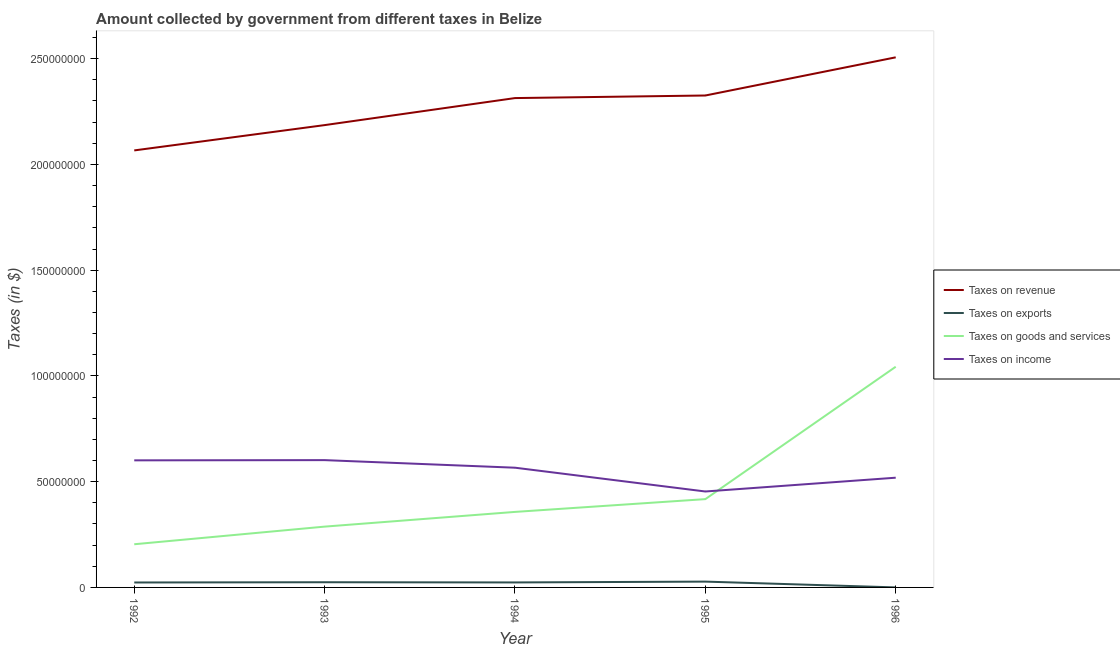Is the number of lines equal to the number of legend labels?
Provide a short and direct response. Yes. What is the amount collected as tax on income in 1996?
Your response must be concise. 5.19e+07. Across all years, what is the maximum amount collected as tax on exports?
Offer a very short reply. 2.75e+06. Across all years, what is the minimum amount collected as tax on goods?
Your answer should be compact. 2.04e+07. In which year was the amount collected as tax on income maximum?
Your answer should be very brief. 1993. What is the total amount collected as tax on revenue in the graph?
Provide a short and direct response. 1.14e+09. What is the difference between the amount collected as tax on revenue in 1992 and that in 1993?
Your answer should be very brief. -1.20e+07. What is the difference between the amount collected as tax on goods in 1994 and the amount collected as tax on exports in 1995?
Make the answer very short. 3.30e+07. What is the average amount collected as tax on goods per year?
Ensure brevity in your answer.  4.62e+07. In the year 1996, what is the difference between the amount collected as tax on revenue and amount collected as tax on income?
Offer a terse response. 1.99e+08. What is the ratio of the amount collected as tax on revenue in 1992 to that in 1995?
Give a very brief answer. 0.89. Is the difference between the amount collected as tax on income in 1995 and 1996 greater than the difference between the amount collected as tax on exports in 1995 and 1996?
Provide a succinct answer. No. What is the difference between the highest and the second highest amount collected as tax on goods?
Provide a succinct answer. 6.26e+07. What is the difference between the highest and the lowest amount collected as tax on exports?
Your answer should be compact. 2.74e+06. Is the sum of the amount collected as tax on goods in 1992 and 1996 greater than the maximum amount collected as tax on exports across all years?
Your answer should be compact. Yes. Is it the case that in every year, the sum of the amount collected as tax on revenue and amount collected as tax on exports is greater than the amount collected as tax on goods?
Ensure brevity in your answer.  Yes. How many years are there in the graph?
Give a very brief answer. 5. What is the difference between two consecutive major ticks on the Y-axis?
Provide a succinct answer. 5.00e+07. Are the values on the major ticks of Y-axis written in scientific E-notation?
Ensure brevity in your answer.  No. Does the graph contain any zero values?
Offer a terse response. No. Does the graph contain grids?
Your answer should be compact. No. How many legend labels are there?
Offer a terse response. 4. How are the legend labels stacked?
Ensure brevity in your answer.  Vertical. What is the title of the graph?
Your response must be concise. Amount collected by government from different taxes in Belize. Does "Oil" appear as one of the legend labels in the graph?
Your answer should be compact. No. What is the label or title of the X-axis?
Give a very brief answer. Year. What is the label or title of the Y-axis?
Provide a short and direct response. Taxes (in $). What is the Taxes (in $) in Taxes on revenue in 1992?
Provide a short and direct response. 2.07e+08. What is the Taxes (in $) of Taxes on exports in 1992?
Provide a short and direct response. 2.34e+06. What is the Taxes (in $) in Taxes on goods and services in 1992?
Your answer should be very brief. 2.04e+07. What is the Taxes (in $) in Taxes on income in 1992?
Your answer should be compact. 6.01e+07. What is the Taxes (in $) of Taxes on revenue in 1993?
Your answer should be very brief. 2.19e+08. What is the Taxes (in $) of Taxes on exports in 1993?
Your answer should be very brief. 2.45e+06. What is the Taxes (in $) of Taxes on goods and services in 1993?
Give a very brief answer. 2.88e+07. What is the Taxes (in $) in Taxes on income in 1993?
Give a very brief answer. 6.02e+07. What is the Taxes (in $) in Taxes on revenue in 1994?
Make the answer very short. 2.31e+08. What is the Taxes (in $) in Taxes on exports in 1994?
Keep it short and to the point. 2.36e+06. What is the Taxes (in $) in Taxes on goods and services in 1994?
Your answer should be very brief. 3.57e+07. What is the Taxes (in $) of Taxes on income in 1994?
Your response must be concise. 5.66e+07. What is the Taxes (in $) of Taxes on revenue in 1995?
Your answer should be very brief. 2.33e+08. What is the Taxes (in $) in Taxes on exports in 1995?
Your answer should be compact. 2.75e+06. What is the Taxes (in $) in Taxes on goods and services in 1995?
Offer a very short reply. 4.17e+07. What is the Taxes (in $) of Taxes on income in 1995?
Your answer should be compact. 4.54e+07. What is the Taxes (in $) of Taxes on revenue in 1996?
Give a very brief answer. 2.51e+08. What is the Taxes (in $) of Taxes on exports in 1996?
Your response must be concise. 1.20e+04. What is the Taxes (in $) in Taxes on goods and services in 1996?
Provide a short and direct response. 1.04e+08. What is the Taxes (in $) in Taxes on income in 1996?
Make the answer very short. 5.19e+07. Across all years, what is the maximum Taxes (in $) of Taxes on revenue?
Your answer should be compact. 2.51e+08. Across all years, what is the maximum Taxes (in $) in Taxes on exports?
Provide a succinct answer. 2.75e+06. Across all years, what is the maximum Taxes (in $) of Taxes on goods and services?
Your answer should be compact. 1.04e+08. Across all years, what is the maximum Taxes (in $) in Taxes on income?
Offer a very short reply. 6.02e+07. Across all years, what is the minimum Taxes (in $) of Taxes on revenue?
Your response must be concise. 2.07e+08. Across all years, what is the minimum Taxes (in $) in Taxes on exports?
Your answer should be compact. 1.20e+04. Across all years, what is the minimum Taxes (in $) of Taxes on goods and services?
Your response must be concise. 2.04e+07. Across all years, what is the minimum Taxes (in $) in Taxes on income?
Your response must be concise. 4.54e+07. What is the total Taxes (in $) of Taxes on revenue in the graph?
Keep it short and to the point. 1.14e+09. What is the total Taxes (in $) in Taxes on exports in the graph?
Offer a terse response. 9.91e+06. What is the total Taxes (in $) of Taxes on goods and services in the graph?
Make the answer very short. 2.31e+08. What is the total Taxes (in $) of Taxes on income in the graph?
Ensure brevity in your answer.  2.74e+08. What is the difference between the Taxes (in $) in Taxes on revenue in 1992 and that in 1993?
Offer a very short reply. -1.20e+07. What is the difference between the Taxes (in $) of Taxes on exports in 1992 and that in 1993?
Offer a terse response. -1.17e+05. What is the difference between the Taxes (in $) of Taxes on goods and services in 1992 and that in 1993?
Offer a terse response. -8.34e+06. What is the difference between the Taxes (in $) of Taxes on income in 1992 and that in 1993?
Provide a short and direct response. -1.07e+05. What is the difference between the Taxes (in $) of Taxes on revenue in 1992 and that in 1994?
Provide a short and direct response. -2.47e+07. What is the difference between the Taxes (in $) in Taxes on exports in 1992 and that in 1994?
Your answer should be compact. -2.20e+04. What is the difference between the Taxes (in $) of Taxes on goods and services in 1992 and that in 1994?
Offer a very short reply. -1.53e+07. What is the difference between the Taxes (in $) in Taxes on income in 1992 and that in 1994?
Provide a succinct answer. 3.48e+06. What is the difference between the Taxes (in $) in Taxes on revenue in 1992 and that in 1995?
Your response must be concise. -2.60e+07. What is the difference between the Taxes (in $) of Taxes on exports in 1992 and that in 1995?
Ensure brevity in your answer.  -4.11e+05. What is the difference between the Taxes (in $) of Taxes on goods and services in 1992 and that in 1995?
Keep it short and to the point. -2.13e+07. What is the difference between the Taxes (in $) of Taxes on income in 1992 and that in 1995?
Provide a succinct answer. 1.47e+07. What is the difference between the Taxes (in $) of Taxes on revenue in 1992 and that in 1996?
Keep it short and to the point. -4.40e+07. What is the difference between the Taxes (in $) in Taxes on exports in 1992 and that in 1996?
Your response must be concise. 2.32e+06. What is the difference between the Taxes (in $) of Taxes on goods and services in 1992 and that in 1996?
Provide a succinct answer. -8.39e+07. What is the difference between the Taxes (in $) in Taxes on income in 1992 and that in 1996?
Your answer should be very brief. 8.20e+06. What is the difference between the Taxes (in $) in Taxes on revenue in 1993 and that in 1994?
Provide a short and direct response. -1.28e+07. What is the difference between the Taxes (in $) of Taxes on exports in 1993 and that in 1994?
Provide a short and direct response. 9.50e+04. What is the difference between the Taxes (in $) of Taxes on goods and services in 1993 and that in 1994?
Provide a short and direct response. -6.96e+06. What is the difference between the Taxes (in $) of Taxes on income in 1993 and that in 1994?
Make the answer very short. 3.58e+06. What is the difference between the Taxes (in $) in Taxes on revenue in 1993 and that in 1995?
Keep it short and to the point. -1.40e+07. What is the difference between the Taxes (in $) of Taxes on exports in 1993 and that in 1995?
Your answer should be compact. -2.94e+05. What is the difference between the Taxes (in $) in Taxes on goods and services in 1993 and that in 1995?
Offer a terse response. -1.30e+07. What is the difference between the Taxes (in $) in Taxes on income in 1993 and that in 1995?
Your answer should be compact. 1.48e+07. What is the difference between the Taxes (in $) of Taxes on revenue in 1993 and that in 1996?
Provide a succinct answer. -3.20e+07. What is the difference between the Taxes (in $) in Taxes on exports in 1993 and that in 1996?
Give a very brief answer. 2.44e+06. What is the difference between the Taxes (in $) in Taxes on goods and services in 1993 and that in 1996?
Offer a terse response. -7.56e+07. What is the difference between the Taxes (in $) of Taxes on income in 1993 and that in 1996?
Keep it short and to the point. 8.31e+06. What is the difference between the Taxes (in $) of Taxes on revenue in 1994 and that in 1995?
Ensure brevity in your answer.  -1.22e+06. What is the difference between the Taxes (in $) in Taxes on exports in 1994 and that in 1995?
Make the answer very short. -3.89e+05. What is the difference between the Taxes (in $) of Taxes on goods and services in 1994 and that in 1995?
Give a very brief answer. -6.04e+06. What is the difference between the Taxes (in $) in Taxes on income in 1994 and that in 1995?
Keep it short and to the point. 1.12e+07. What is the difference between the Taxes (in $) in Taxes on revenue in 1994 and that in 1996?
Offer a very short reply. -1.93e+07. What is the difference between the Taxes (in $) in Taxes on exports in 1994 and that in 1996?
Your answer should be very brief. 2.35e+06. What is the difference between the Taxes (in $) in Taxes on goods and services in 1994 and that in 1996?
Provide a succinct answer. -6.86e+07. What is the difference between the Taxes (in $) in Taxes on income in 1994 and that in 1996?
Your answer should be very brief. 4.73e+06. What is the difference between the Taxes (in $) of Taxes on revenue in 1995 and that in 1996?
Provide a succinct answer. -1.80e+07. What is the difference between the Taxes (in $) of Taxes on exports in 1995 and that in 1996?
Your response must be concise. 2.74e+06. What is the difference between the Taxes (in $) of Taxes on goods and services in 1995 and that in 1996?
Provide a short and direct response. -6.26e+07. What is the difference between the Taxes (in $) of Taxes on income in 1995 and that in 1996?
Provide a short and direct response. -6.52e+06. What is the difference between the Taxes (in $) of Taxes on revenue in 1992 and the Taxes (in $) of Taxes on exports in 1993?
Your answer should be compact. 2.04e+08. What is the difference between the Taxes (in $) in Taxes on revenue in 1992 and the Taxes (in $) in Taxes on goods and services in 1993?
Your response must be concise. 1.78e+08. What is the difference between the Taxes (in $) in Taxes on revenue in 1992 and the Taxes (in $) in Taxes on income in 1993?
Provide a short and direct response. 1.46e+08. What is the difference between the Taxes (in $) in Taxes on exports in 1992 and the Taxes (in $) in Taxes on goods and services in 1993?
Provide a short and direct response. -2.64e+07. What is the difference between the Taxes (in $) in Taxes on exports in 1992 and the Taxes (in $) in Taxes on income in 1993?
Keep it short and to the point. -5.79e+07. What is the difference between the Taxes (in $) of Taxes on goods and services in 1992 and the Taxes (in $) of Taxes on income in 1993?
Your answer should be very brief. -3.98e+07. What is the difference between the Taxes (in $) in Taxes on revenue in 1992 and the Taxes (in $) in Taxes on exports in 1994?
Offer a terse response. 2.04e+08. What is the difference between the Taxes (in $) in Taxes on revenue in 1992 and the Taxes (in $) in Taxes on goods and services in 1994?
Make the answer very short. 1.71e+08. What is the difference between the Taxes (in $) of Taxes on revenue in 1992 and the Taxes (in $) of Taxes on income in 1994?
Provide a short and direct response. 1.50e+08. What is the difference between the Taxes (in $) of Taxes on exports in 1992 and the Taxes (in $) of Taxes on goods and services in 1994?
Make the answer very short. -3.34e+07. What is the difference between the Taxes (in $) of Taxes on exports in 1992 and the Taxes (in $) of Taxes on income in 1994?
Offer a terse response. -5.43e+07. What is the difference between the Taxes (in $) of Taxes on goods and services in 1992 and the Taxes (in $) of Taxes on income in 1994?
Provide a succinct answer. -3.62e+07. What is the difference between the Taxes (in $) in Taxes on revenue in 1992 and the Taxes (in $) in Taxes on exports in 1995?
Offer a very short reply. 2.04e+08. What is the difference between the Taxes (in $) of Taxes on revenue in 1992 and the Taxes (in $) of Taxes on goods and services in 1995?
Give a very brief answer. 1.65e+08. What is the difference between the Taxes (in $) in Taxes on revenue in 1992 and the Taxes (in $) in Taxes on income in 1995?
Provide a succinct answer. 1.61e+08. What is the difference between the Taxes (in $) of Taxes on exports in 1992 and the Taxes (in $) of Taxes on goods and services in 1995?
Offer a terse response. -3.94e+07. What is the difference between the Taxes (in $) in Taxes on exports in 1992 and the Taxes (in $) in Taxes on income in 1995?
Keep it short and to the point. -4.30e+07. What is the difference between the Taxes (in $) in Taxes on goods and services in 1992 and the Taxes (in $) in Taxes on income in 1995?
Give a very brief answer. -2.49e+07. What is the difference between the Taxes (in $) of Taxes on revenue in 1992 and the Taxes (in $) of Taxes on exports in 1996?
Keep it short and to the point. 2.07e+08. What is the difference between the Taxes (in $) of Taxes on revenue in 1992 and the Taxes (in $) of Taxes on goods and services in 1996?
Provide a short and direct response. 1.02e+08. What is the difference between the Taxes (in $) in Taxes on revenue in 1992 and the Taxes (in $) in Taxes on income in 1996?
Provide a short and direct response. 1.55e+08. What is the difference between the Taxes (in $) in Taxes on exports in 1992 and the Taxes (in $) in Taxes on goods and services in 1996?
Provide a short and direct response. -1.02e+08. What is the difference between the Taxes (in $) of Taxes on exports in 1992 and the Taxes (in $) of Taxes on income in 1996?
Ensure brevity in your answer.  -4.95e+07. What is the difference between the Taxes (in $) of Taxes on goods and services in 1992 and the Taxes (in $) of Taxes on income in 1996?
Your answer should be compact. -3.15e+07. What is the difference between the Taxes (in $) in Taxes on revenue in 1993 and the Taxes (in $) in Taxes on exports in 1994?
Provide a succinct answer. 2.16e+08. What is the difference between the Taxes (in $) in Taxes on revenue in 1993 and the Taxes (in $) in Taxes on goods and services in 1994?
Provide a short and direct response. 1.83e+08. What is the difference between the Taxes (in $) of Taxes on revenue in 1993 and the Taxes (in $) of Taxes on income in 1994?
Keep it short and to the point. 1.62e+08. What is the difference between the Taxes (in $) in Taxes on exports in 1993 and the Taxes (in $) in Taxes on goods and services in 1994?
Offer a terse response. -3.33e+07. What is the difference between the Taxes (in $) of Taxes on exports in 1993 and the Taxes (in $) of Taxes on income in 1994?
Offer a very short reply. -5.42e+07. What is the difference between the Taxes (in $) of Taxes on goods and services in 1993 and the Taxes (in $) of Taxes on income in 1994?
Provide a succinct answer. -2.79e+07. What is the difference between the Taxes (in $) in Taxes on revenue in 1993 and the Taxes (in $) in Taxes on exports in 1995?
Provide a short and direct response. 2.16e+08. What is the difference between the Taxes (in $) of Taxes on revenue in 1993 and the Taxes (in $) of Taxes on goods and services in 1995?
Provide a succinct answer. 1.77e+08. What is the difference between the Taxes (in $) in Taxes on revenue in 1993 and the Taxes (in $) in Taxes on income in 1995?
Give a very brief answer. 1.73e+08. What is the difference between the Taxes (in $) in Taxes on exports in 1993 and the Taxes (in $) in Taxes on goods and services in 1995?
Offer a very short reply. -3.93e+07. What is the difference between the Taxes (in $) in Taxes on exports in 1993 and the Taxes (in $) in Taxes on income in 1995?
Offer a very short reply. -4.29e+07. What is the difference between the Taxes (in $) of Taxes on goods and services in 1993 and the Taxes (in $) of Taxes on income in 1995?
Offer a terse response. -1.66e+07. What is the difference between the Taxes (in $) in Taxes on revenue in 1993 and the Taxes (in $) in Taxes on exports in 1996?
Your answer should be very brief. 2.19e+08. What is the difference between the Taxes (in $) in Taxes on revenue in 1993 and the Taxes (in $) in Taxes on goods and services in 1996?
Your answer should be compact. 1.14e+08. What is the difference between the Taxes (in $) in Taxes on revenue in 1993 and the Taxes (in $) in Taxes on income in 1996?
Provide a succinct answer. 1.67e+08. What is the difference between the Taxes (in $) of Taxes on exports in 1993 and the Taxes (in $) of Taxes on goods and services in 1996?
Provide a short and direct response. -1.02e+08. What is the difference between the Taxes (in $) of Taxes on exports in 1993 and the Taxes (in $) of Taxes on income in 1996?
Give a very brief answer. -4.94e+07. What is the difference between the Taxes (in $) of Taxes on goods and services in 1993 and the Taxes (in $) of Taxes on income in 1996?
Ensure brevity in your answer.  -2.31e+07. What is the difference between the Taxes (in $) in Taxes on revenue in 1994 and the Taxes (in $) in Taxes on exports in 1995?
Provide a succinct answer. 2.29e+08. What is the difference between the Taxes (in $) in Taxes on revenue in 1994 and the Taxes (in $) in Taxes on goods and services in 1995?
Your answer should be very brief. 1.90e+08. What is the difference between the Taxes (in $) in Taxes on revenue in 1994 and the Taxes (in $) in Taxes on income in 1995?
Offer a terse response. 1.86e+08. What is the difference between the Taxes (in $) in Taxes on exports in 1994 and the Taxes (in $) in Taxes on goods and services in 1995?
Your answer should be compact. -3.94e+07. What is the difference between the Taxes (in $) of Taxes on exports in 1994 and the Taxes (in $) of Taxes on income in 1995?
Your response must be concise. -4.30e+07. What is the difference between the Taxes (in $) of Taxes on goods and services in 1994 and the Taxes (in $) of Taxes on income in 1995?
Offer a terse response. -9.65e+06. What is the difference between the Taxes (in $) in Taxes on revenue in 1994 and the Taxes (in $) in Taxes on exports in 1996?
Ensure brevity in your answer.  2.31e+08. What is the difference between the Taxes (in $) of Taxes on revenue in 1994 and the Taxes (in $) of Taxes on goods and services in 1996?
Ensure brevity in your answer.  1.27e+08. What is the difference between the Taxes (in $) in Taxes on revenue in 1994 and the Taxes (in $) in Taxes on income in 1996?
Ensure brevity in your answer.  1.79e+08. What is the difference between the Taxes (in $) of Taxes on exports in 1994 and the Taxes (in $) of Taxes on goods and services in 1996?
Make the answer very short. -1.02e+08. What is the difference between the Taxes (in $) in Taxes on exports in 1994 and the Taxes (in $) in Taxes on income in 1996?
Make the answer very short. -4.95e+07. What is the difference between the Taxes (in $) of Taxes on goods and services in 1994 and the Taxes (in $) of Taxes on income in 1996?
Provide a succinct answer. -1.62e+07. What is the difference between the Taxes (in $) of Taxes on revenue in 1995 and the Taxes (in $) of Taxes on exports in 1996?
Keep it short and to the point. 2.33e+08. What is the difference between the Taxes (in $) in Taxes on revenue in 1995 and the Taxes (in $) in Taxes on goods and services in 1996?
Offer a terse response. 1.28e+08. What is the difference between the Taxes (in $) of Taxes on revenue in 1995 and the Taxes (in $) of Taxes on income in 1996?
Provide a short and direct response. 1.81e+08. What is the difference between the Taxes (in $) in Taxes on exports in 1995 and the Taxes (in $) in Taxes on goods and services in 1996?
Your answer should be compact. -1.02e+08. What is the difference between the Taxes (in $) of Taxes on exports in 1995 and the Taxes (in $) of Taxes on income in 1996?
Offer a terse response. -4.91e+07. What is the difference between the Taxes (in $) of Taxes on goods and services in 1995 and the Taxes (in $) of Taxes on income in 1996?
Your response must be concise. -1.01e+07. What is the average Taxes (in $) in Taxes on revenue per year?
Your response must be concise. 2.28e+08. What is the average Taxes (in $) in Taxes on exports per year?
Your answer should be compact. 1.98e+06. What is the average Taxes (in $) in Taxes on goods and services per year?
Offer a terse response. 4.62e+07. What is the average Taxes (in $) in Taxes on income per year?
Give a very brief answer. 5.48e+07. In the year 1992, what is the difference between the Taxes (in $) of Taxes on revenue and Taxes (in $) of Taxes on exports?
Make the answer very short. 2.04e+08. In the year 1992, what is the difference between the Taxes (in $) of Taxes on revenue and Taxes (in $) of Taxes on goods and services?
Provide a short and direct response. 1.86e+08. In the year 1992, what is the difference between the Taxes (in $) of Taxes on revenue and Taxes (in $) of Taxes on income?
Keep it short and to the point. 1.47e+08. In the year 1992, what is the difference between the Taxes (in $) of Taxes on exports and Taxes (in $) of Taxes on goods and services?
Your answer should be compact. -1.81e+07. In the year 1992, what is the difference between the Taxes (in $) in Taxes on exports and Taxes (in $) in Taxes on income?
Offer a very short reply. -5.78e+07. In the year 1992, what is the difference between the Taxes (in $) in Taxes on goods and services and Taxes (in $) in Taxes on income?
Offer a very short reply. -3.97e+07. In the year 1993, what is the difference between the Taxes (in $) in Taxes on revenue and Taxes (in $) in Taxes on exports?
Your answer should be very brief. 2.16e+08. In the year 1993, what is the difference between the Taxes (in $) of Taxes on revenue and Taxes (in $) of Taxes on goods and services?
Provide a succinct answer. 1.90e+08. In the year 1993, what is the difference between the Taxes (in $) in Taxes on revenue and Taxes (in $) in Taxes on income?
Give a very brief answer. 1.58e+08. In the year 1993, what is the difference between the Taxes (in $) in Taxes on exports and Taxes (in $) in Taxes on goods and services?
Provide a short and direct response. -2.63e+07. In the year 1993, what is the difference between the Taxes (in $) in Taxes on exports and Taxes (in $) in Taxes on income?
Your answer should be very brief. -5.77e+07. In the year 1993, what is the difference between the Taxes (in $) in Taxes on goods and services and Taxes (in $) in Taxes on income?
Provide a succinct answer. -3.14e+07. In the year 1994, what is the difference between the Taxes (in $) of Taxes on revenue and Taxes (in $) of Taxes on exports?
Offer a very short reply. 2.29e+08. In the year 1994, what is the difference between the Taxes (in $) in Taxes on revenue and Taxes (in $) in Taxes on goods and services?
Provide a short and direct response. 1.96e+08. In the year 1994, what is the difference between the Taxes (in $) of Taxes on revenue and Taxes (in $) of Taxes on income?
Your response must be concise. 1.75e+08. In the year 1994, what is the difference between the Taxes (in $) in Taxes on exports and Taxes (in $) in Taxes on goods and services?
Provide a short and direct response. -3.34e+07. In the year 1994, what is the difference between the Taxes (in $) of Taxes on exports and Taxes (in $) of Taxes on income?
Your response must be concise. -5.43e+07. In the year 1994, what is the difference between the Taxes (in $) in Taxes on goods and services and Taxes (in $) in Taxes on income?
Ensure brevity in your answer.  -2.09e+07. In the year 1995, what is the difference between the Taxes (in $) of Taxes on revenue and Taxes (in $) of Taxes on exports?
Your response must be concise. 2.30e+08. In the year 1995, what is the difference between the Taxes (in $) in Taxes on revenue and Taxes (in $) in Taxes on goods and services?
Provide a succinct answer. 1.91e+08. In the year 1995, what is the difference between the Taxes (in $) of Taxes on revenue and Taxes (in $) of Taxes on income?
Your answer should be compact. 1.87e+08. In the year 1995, what is the difference between the Taxes (in $) of Taxes on exports and Taxes (in $) of Taxes on goods and services?
Make the answer very short. -3.90e+07. In the year 1995, what is the difference between the Taxes (in $) of Taxes on exports and Taxes (in $) of Taxes on income?
Your answer should be compact. -4.26e+07. In the year 1995, what is the difference between the Taxes (in $) of Taxes on goods and services and Taxes (in $) of Taxes on income?
Provide a succinct answer. -3.61e+06. In the year 1996, what is the difference between the Taxes (in $) in Taxes on revenue and Taxes (in $) in Taxes on exports?
Give a very brief answer. 2.51e+08. In the year 1996, what is the difference between the Taxes (in $) in Taxes on revenue and Taxes (in $) in Taxes on goods and services?
Keep it short and to the point. 1.46e+08. In the year 1996, what is the difference between the Taxes (in $) in Taxes on revenue and Taxes (in $) in Taxes on income?
Make the answer very short. 1.99e+08. In the year 1996, what is the difference between the Taxes (in $) of Taxes on exports and Taxes (in $) of Taxes on goods and services?
Give a very brief answer. -1.04e+08. In the year 1996, what is the difference between the Taxes (in $) in Taxes on exports and Taxes (in $) in Taxes on income?
Offer a very short reply. -5.19e+07. In the year 1996, what is the difference between the Taxes (in $) in Taxes on goods and services and Taxes (in $) in Taxes on income?
Provide a short and direct response. 5.25e+07. What is the ratio of the Taxes (in $) in Taxes on revenue in 1992 to that in 1993?
Make the answer very short. 0.95. What is the ratio of the Taxes (in $) of Taxes on exports in 1992 to that in 1993?
Give a very brief answer. 0.95. What is the ratio of the Taxes (in $) of Taxes on goods and services in 1992 to that in 1993?
Ensure brevity in your answer.  0.71. What is the ratio of the Taxes (in $) in Taxes on income in 1992 to that in 1993?
Your answer should be very brief. 1. What is the ratio of the Taxes (in $) of Taxes on revenue in 1992 to that in 1994?
Your response must be concise. 0.89. What is the ratio of the Taxes (in $) of Taxes on exports in 1992 to that in 1994?
Ensure brevity in your answer.  0.99. What is the ratio of the Taxes (in $) of Taxes on goods and services in 1992 to that in 1994?
Offer a very short reply. 0.57. What is the ratio of the Taxes (in $) of Taxes on income in 1992 to that in 1994?
Your answer should be very brief. 1.06. What is the ratio of the Taxes (in $) of Taxes on revenue in 1992 to that in 1995?
Give a very brief answer. 0.89. What is the ratio of the Taxes (in $) in Taxes on exports in 1992 to that in 1995?
Your answer should be very brief. 0.85. What is the ratio of the Taxes (in $) of Taxes on goods and services in 1992 to that in 1995?
Your answer should be very brief. 0.49. What is the ratio of the Taxes (in $) of Taxes on income in 1992 to that in 1995?
Provide a succinct answer. 1.32. What is the ratio of the Taxes (in $) in Taxes on revenue in 1992 to that in 1996?
Make the answer very short. 0.82. What is the ratio of the Taxes (in $) in Taxes on exports in 1992 to that in 1996?
Provide a succinct answer. 194.67. What is the ratio of the Taxes (in $) in Taxes on goods and services in 1992 to that in 1996?
Your answer should be compact. 0.2. What is the ratio of the Taxes (in $) of Taxes on income in 1992 to that in 1996?
Give a very brief answer. 1.16. What is the ratio of the Taxes (in $) of Taxes on revenue in 1993 to that in 1994?
Your answer should be compact. 0.94. What is the ratio of the Taxes (in $) in Taxes on exports in 1993 to that in 1994?
Your answer should be compact. 1.04. What is the ratio of the Taxes (in $) in Taxes on goods and services in 1993 to that in 1994?
Your response must be concise. 0.81. What is the ratio of the Taxes (in $) of Taxes on income in 1993 to that in 1994?
Your response must be concise. 1.06. What is the ratio of the Taxes (in $) in Taxes on revenue in 1993 to that in 1995?
Ensure brevity in your answer.  0.94. What is the ratio of the Taxes (in $) in Taxes on exports in 1993 to that in 1995?
Provide a short and direct response. 0.89. What is the ratio of the Taxes (in $) of Taxes on goods and services in 1993 to that in 1995?
Make the answer very short. 0.69. What is the ratio of the Taxes (in $) in Taxes on income in 1993 to that in 1995?
Your answer should be very brief. 1.33. What is the ratio of the Taxes (in $) of Taxes on revenue in 1993 to that in 1996?
Keep it short and to the point. 0.87. What is the ratio of the Taxes (in $) in Taxes on exports in 1993 to that in 1996?
Make the answer very short. 204.42. What is the ratio of the Taxes (in $) of Taxes on goods and services in 1993 to that in 1996?
Make the answer very short. 0.28. What is the ratio of the Taxes (in $) in Taxes on income in 1993 to that in 1996?
Ensure brevity in your answer.  1.16. What is the ratio of the Taxes (in $) of Taxes on exports in 1994 to that in 1995?
Make the answer very short. 0.86. What is the ratio of the Taxes (in $) of Taxes on goods and services in 1994 to that in 1995?
Your response must be concise. 0.86. What is the ratio of the Taxes (in $) in Taxes on income in 1994 to that in 1995?
Your response must be concise. 1.25. What is the ratio of the Taxes (in $) of Taxes on revenue in 1994 to that in 1996?
Provide a succinct answer. 0.92. What is the ratio of the Taxes (in $) of Taxes on exports in 1994 to that in 1996?
Offer a very short reply. 196.5. What is the ratio of the Taxes (in $) of Taxes on goods and services in 1994 to that in 1996?
Give a very brief answer. 0.34. What is the ratio of the Taxes (in $) in Taxes on income in 1994 to that in 1996?
Your answer should be very brief. 1.09. What is the ratio of the Taxes (in $) in Taxes on revenue in 1995 to that in 1996?
Ensure brevity in your answer.  0.93. What is the ratio of the Taxes (in $) of Taxes on exports in 1995 to that in 1996?
Make the answer very short. 228.92. What is the ratio of the Taxes (in $) in Taxes on goods and services in 1995 to that in 1996?
Offer a terse response. 0.4. What is the ratio of the Taxes (in $) of Taxes on income in 1995 to that in 1996?
Keep it short and to the point. 0.87. What is the difference between the highest and the second highest Taxes (in $) in Taxes on revenue?
Give a very brief answer. 1.80e+07. What is the difference between the highest and the second highest Taxes (in $) in Taxes on exports?
Your answer should be compact. 2.94e+05. What is the difference between the highest and the second highest Taxes (in $) of Taxes on goods and services?
Give a very brief answer. 6.26e+07. What is the difference between the highest and the second highest Taxes (in $) of Taxes on income?
Your answer should be compact. 1.07e+05. What is the difference between the highest and the lowest Taxes (in $) of Taxes on revenue?
Ensure brevity in your answer.  4.40e+07. What is the difference between the highest and the lowest Taxes (in $) of Taxes on exports?
Offer a very short reply. 2.74e+06. What is the difference between the highest and the lowest Taxes (in $) of Taxes on goods and services?
Make the answer very short. 8.39e+07. What is the difference between the highest and the lowest Taxes (in $) of Taxes on income?
Your answer should be very brief. 1.48e+07. 